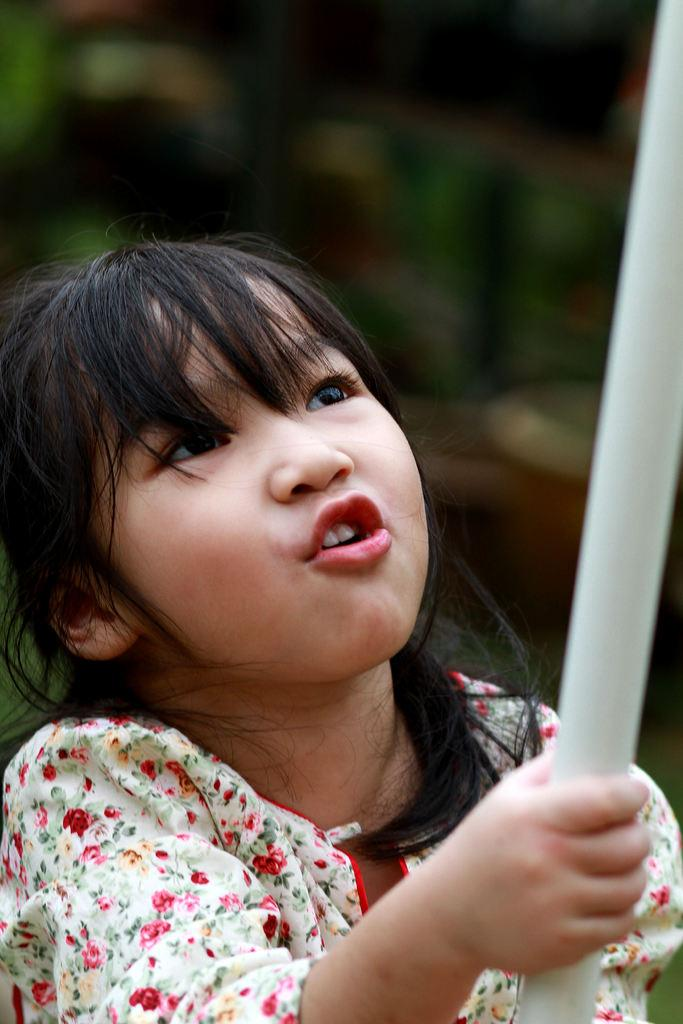Who is the main subject in the picture? There is a girl in the picture. What is the girl holding in the image? The girl is holding an object. Can you describe the background of the image? The background of the image is blurred. What type of bird can be seen flying in the background of the image? There is no bird visible in the image, as the background is blurred. 